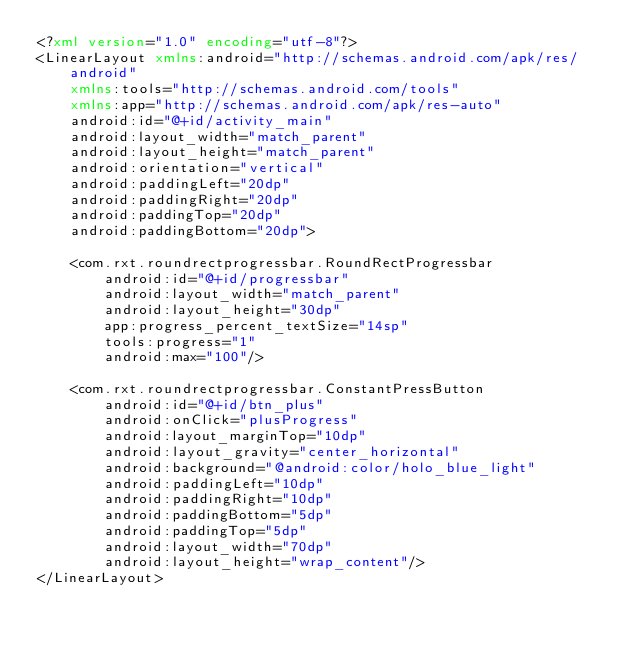Convert code to text. <code><loc_0><loc_0><loc_500><loc_500><_XML_><?xml version="1.0" encoding="utf-8"?>
<LinearLayout xmlns:android="http://schemas.android.com/apk/res/android"
    xmlns:tools="http://schemas.android.com/tools"
    xmlns:app="http://schemas.android.com/apk/res-auto"
    android:id="@+id/activity_main"
    android:layout_width="match_parent"
    android:layout_height="match_parent"
    android:orientation="vertical"
    android:paddingLeft="20dp"
    android:paddingRight="20dp"
    android:paddingTop="20dp"
    android:paddingBottom="20dp">

    <com.rxt.roundrectprogressbar.RoundRectProgressbar
        android:id="@+id/progressbar"
        android:layout_width="match_parent"
        android:layout_height="30dp"
        app:progress_percent_textSize="14sp"
        tools:progress="1"
        android:max="100"/>
    
    <com.rxt.roundrectprogressbar.ConstantPressButton
        android:id="@+id/btn_plus"
        android:onClick="plusProgress"
        android:layout_marginTop="10dp"
        android:layout_gravity="center_horizontal"
        android:background="@android:color/holo_blue_light"
        android:paddingLeft="10dp"
        android:paddingRight="10dp"
        android:paddingBottom="5dp"
        android:paddingTop="5dp"
        android:layout_width="70dp"
        android:layout_height="wrap_content"/>
</LinearLayout>
</code> 